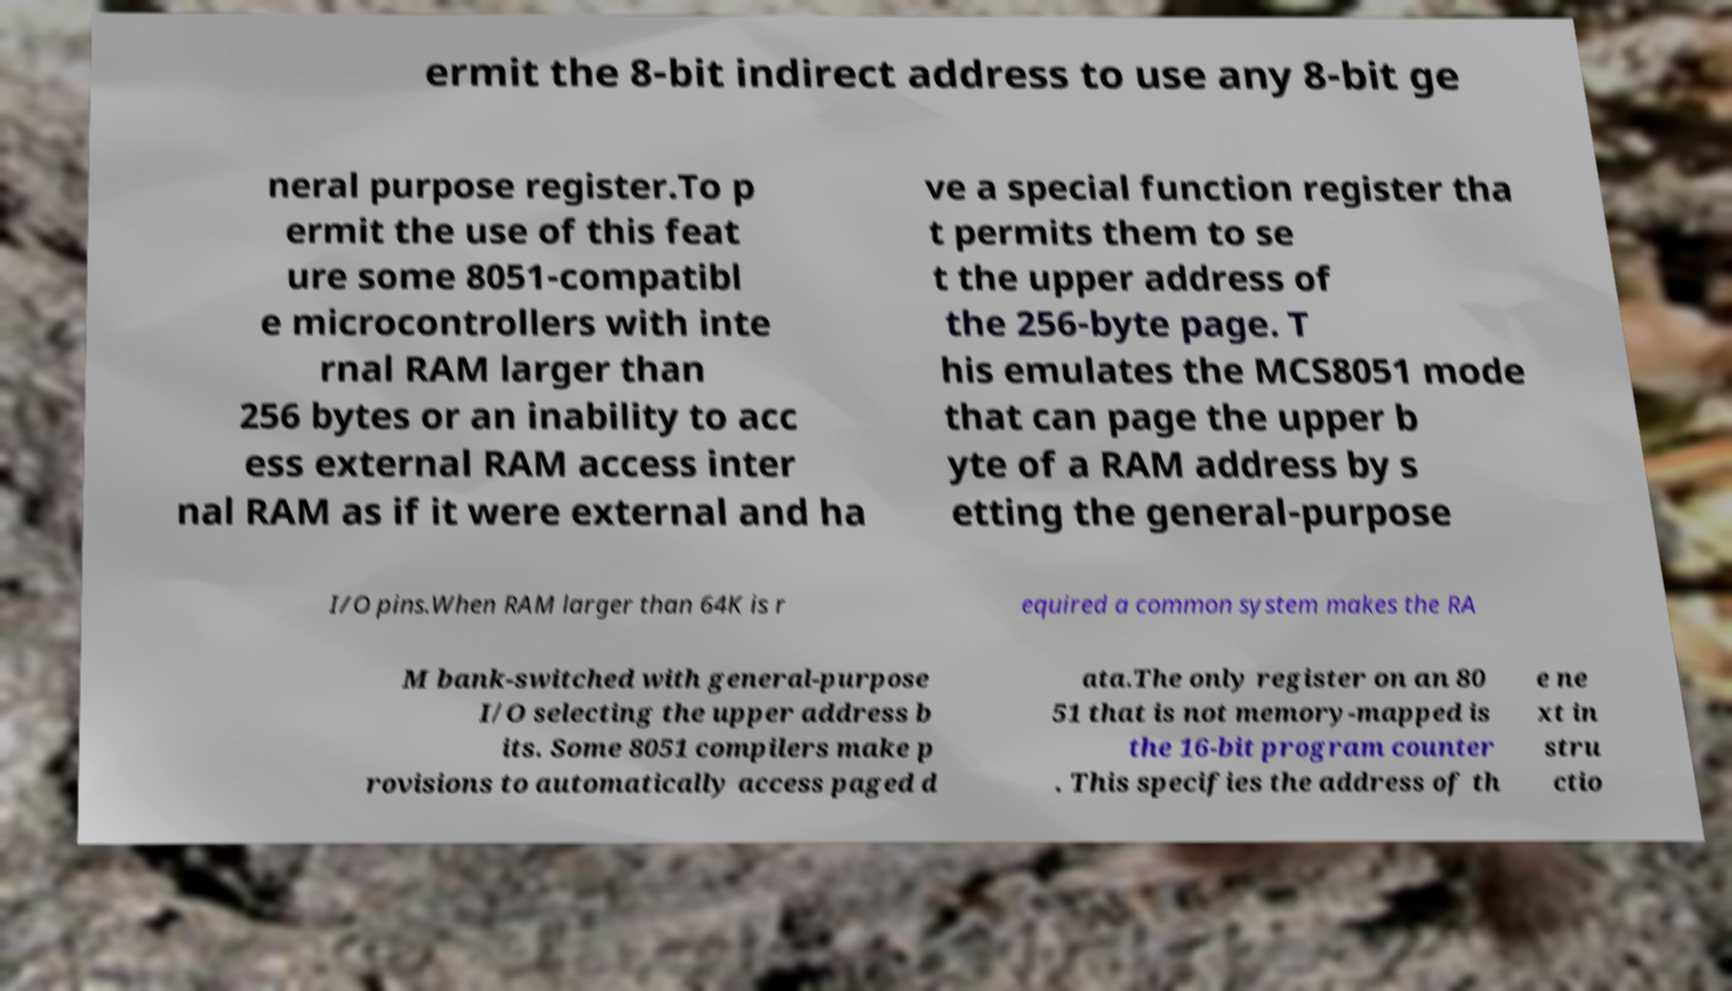Can you read and provide the text displayed in the image?This photo seems to have some interesting text. Can you extract and type it out for me? ermit the 8-bit indirect address to use any 8-bit ge neral purpose register.To p ermit the use of this feat ure some 8051-compatibl e microcontrollers with inte rnal RAM larger than 256 bytes or an inability to acc ess external RAM access inter nal RAM as if it were external and ha ve a special function register tha t permits them to se t the upper address of the 256-byte page. T his emulates the MCS8051 mode that can page the upper b yte of a RAM address by s etting the general-purpose I/O pins.When RAM larger than 64K is r equired a common system makes the RA M bank-switched with general-purpose I/O selecting the upper address b its. Some 8051 compilers make p rovisions to automatically access paged d ata.The only register on an 80 51 that is not memory-mapped is the 16-bit program counter . This specifies the address of th e ne xt in stru ctio 